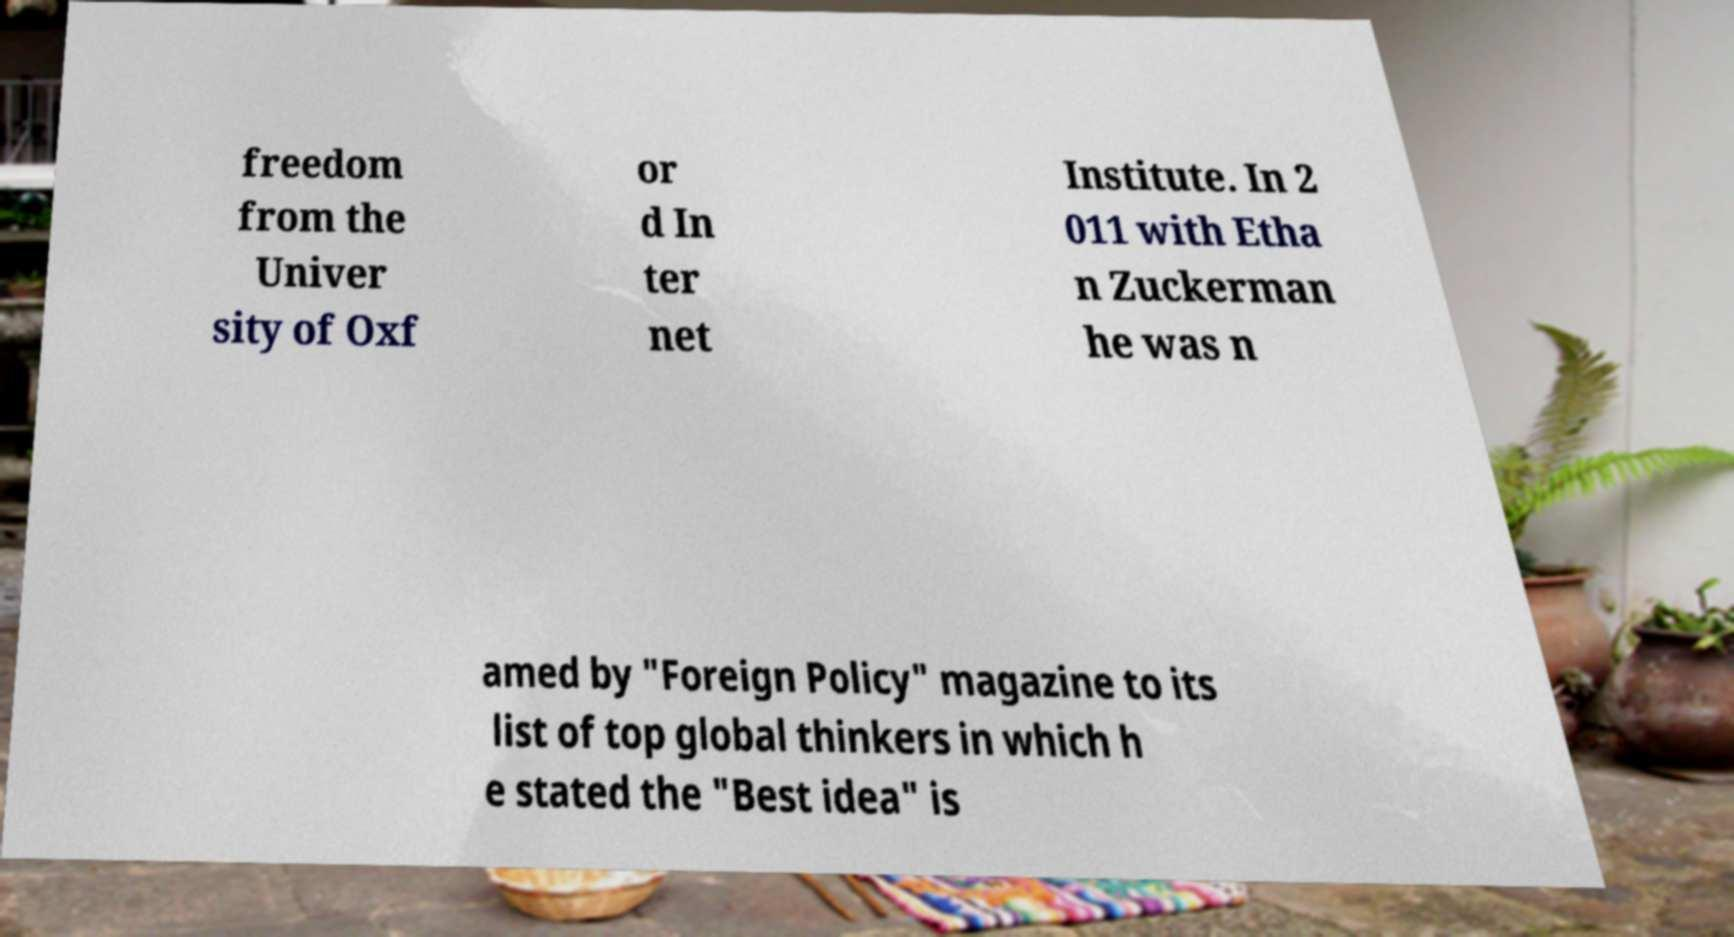Please read and relay the text visible in this image. What does it say? freedom from the Univer sity of Oxf or d In ter net Institute. In 2 011 with Etha n Zuckerman he was n amed by "Foreign Policy" magazine to its list of top global thinkers in which h e stated the "Best idea" is 